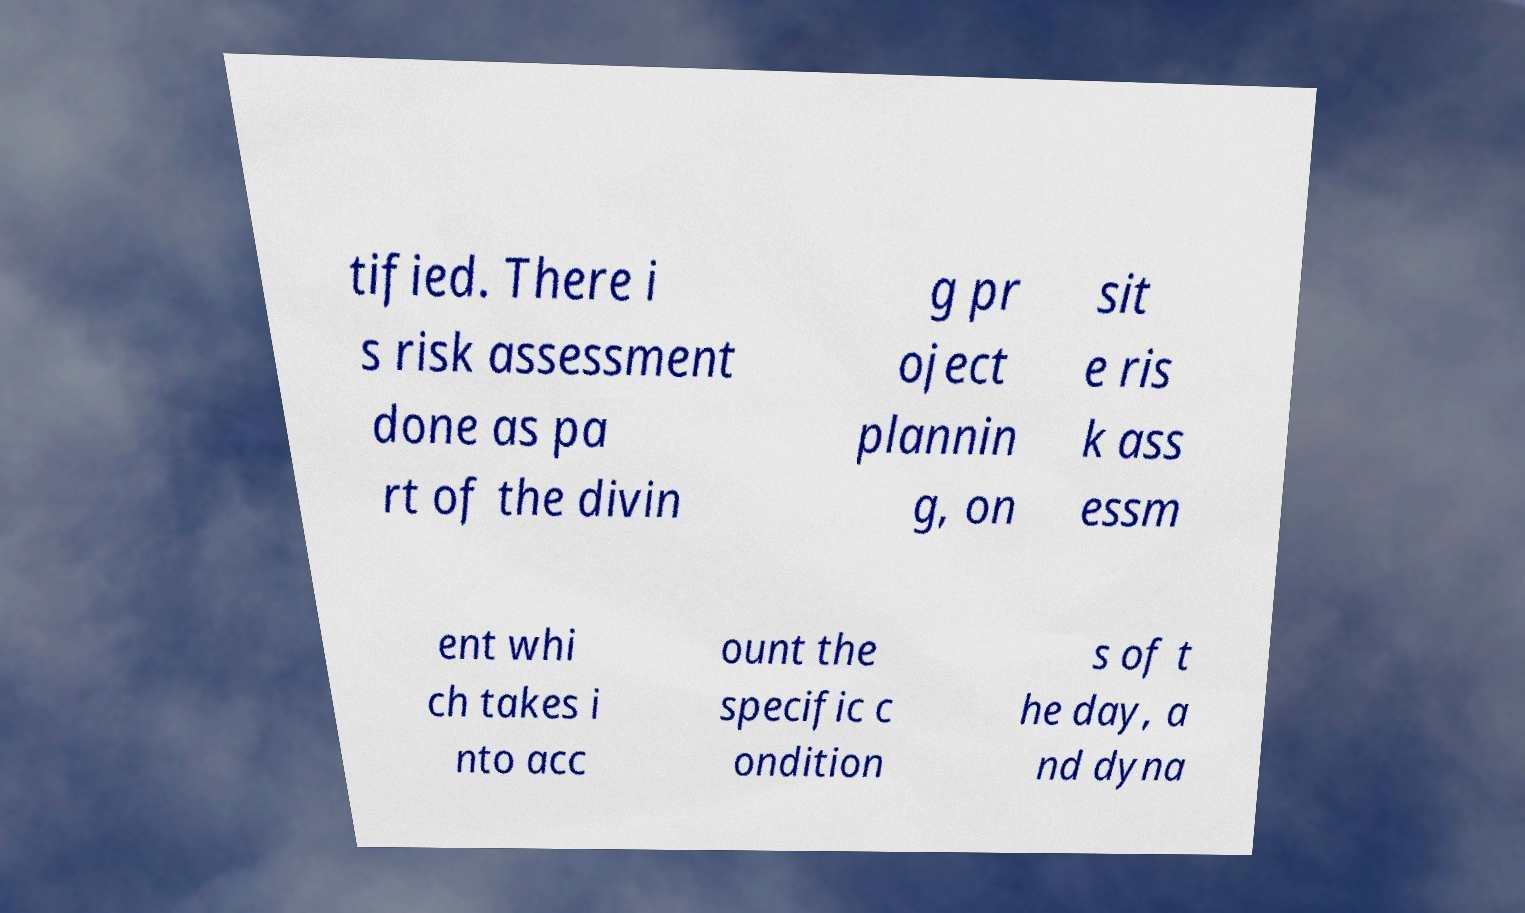Can you read and provide the text displayed in the image?This photo seems to have some interesting text. Can you extract and type it out for me? tified. There i s risk assessment done as pa rt of the divin g pr oject plannin g, on sit e ris k ass essm ent whi ch takes i nto acc ount the specific c ondition s of t he day, a nd dyna 